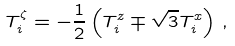<formula> <loc_0><loc_0><loc_500><loc_500>T _ { i } ^ { \zeta } = - \frac { 1 } { 2 } \left ( T _ { i } ^ { z } \mp \sqrt { 3 } T _ { i } ^ { x } \right ) \, ,</formula> 